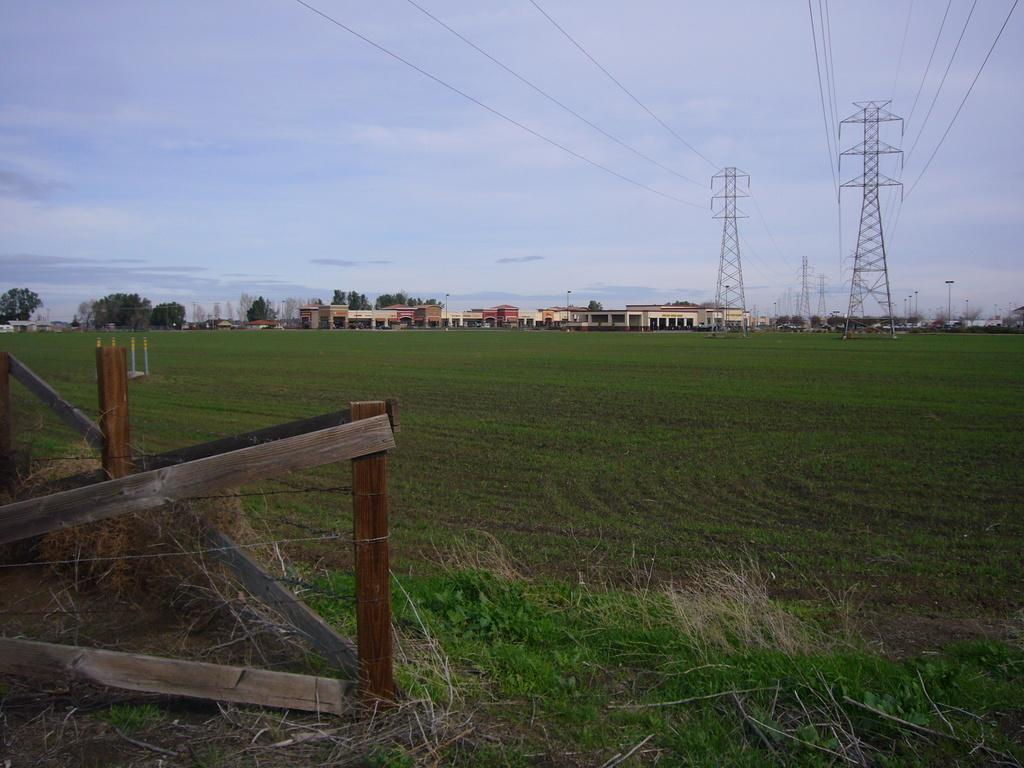What is located on the grassland in the image? There is a fence on the grassland in the image. What can be seen on the right side of the image? There are towers on the right side of the image. How are the towers connected? The towers are connected with wires. What is visible in the background of the image? There are buildings in the background of the image. What is visible at the top of the image? The sky is visible at the top of the image. How many apples are hanging from the fence in the image? There are no apples present in the image; it features a fence on the grassland. What part of the fence is made of gold in the image? There is no part of the fence made of gold in the image; the fence appears to be made of a standard material. 